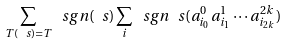<formula> <loc_0><loc_0><loc_500><loc_500>\sum _ { T ( \ s ) = T } \ s g n ( \ s ) \sum _ { i } \ s g n _ { \ } s ( a ^ { 0 } _ { i _ { 0 } } a ^ { 1 } _ { i _ { 1 } } \cdots a ^ { 2 k } _ { i _ { 2 k } } )</formula> 